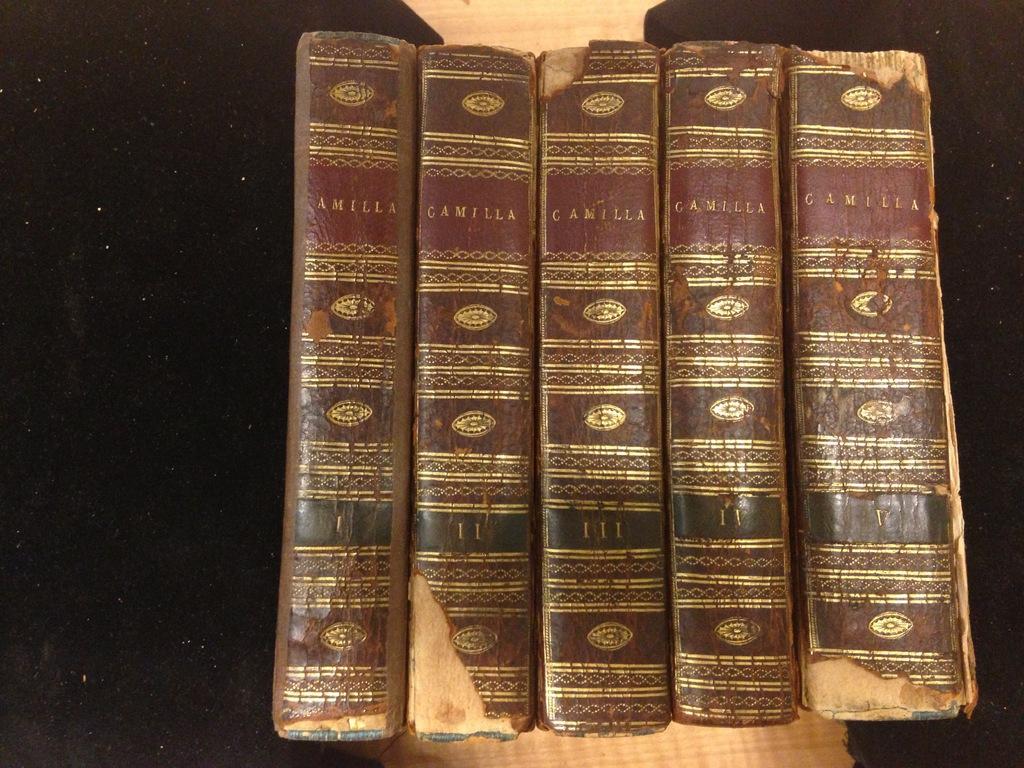What is the title of these book volumes?
Keep it short and to the point. Camilla. How many volumes are in this book series?
Offer a very short reply. 5. 